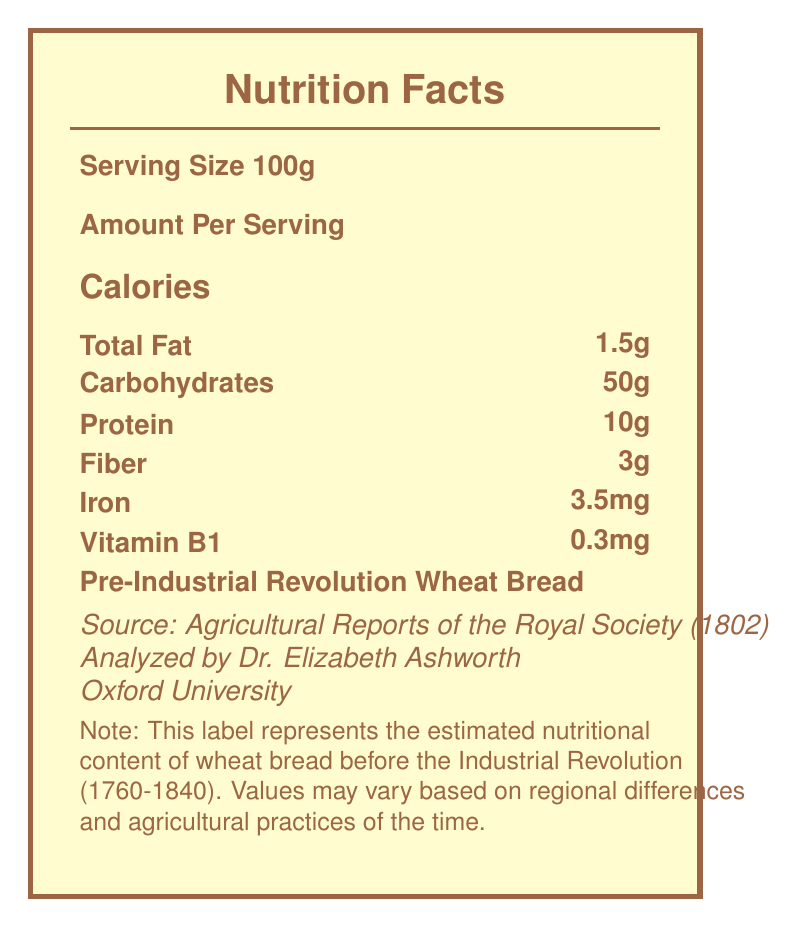who is the researcher mentioned in the document? The document states that Dr. Elizabeth Ashworth, a History Professor at Oxford University, conducted the research.
Answer: Dr. Elizabeth Ashworth what is the average decrease in iron content from pre to post-industrial staple foods? Under the "nutrient changes" section, it specifies an average decrease of 18% in iron content due to soil depletion and faster-growing varieties.
Answer: 18% what is the serving size of the food analyzed? The serving size mentioned in the document is 100g for both pre and post-industrial staple foods.
Answer: 100g how much did the calorie content of wheat bread increase after the Industrial Revolution? The calorie content increased from 250 calories (pre-industrial) to 265 calories (post-industrial), resulting in an increase of 15 calories.
Answer: 15 calories which vitamin's average content decreased by 15% due to storage methods and transportation time? The document lists that vitamin content decreased by 15% due to storage methods and transportation time in the "nutrient changes" section.
Answer: Vitamin content what caused an average decrease in fiber content? The document states that the average decrease of 12% in fiber content is due to the refinement of grains and milling processes.
Answer: Refinement of grains and milling processes by what percentage did pre-industrial revolution wheat bread have more protein compared to post-industrial wheat bread? A. 10% B. 11.1% C. 12.5% D. 14.3% Pre-industrial wheat bread had 10g of protein while post-industrial had 9g, resulting in (10-9)/9*100% = 11.1% more protein pre-industrial.
Answer: B. 11.1% which of the following is not mentioned as an industrial impact on staple foods? 1. Mechanization of farming 2. Food preservation techniques 3. Development of GMOs 4. Urbanization and changing dietary patterns The document lists "Introduction of chemical fertilizers," "Mechanization of farming," "Food preservation techniques," and "Urbanization and changing dietary patterns," but does not mention the development of GMOs.
Answer: 3. Development of GMOs is vitamin C content higher in pre-industrial or post-industrial potatoes? The document shows that pre-industrial potatoes have 19.7mg of vitamin C compared to 17.1mg in post-industrial potatoes, indicating higher content in pre-industrial potatoes.
Answer: Pre-industrial summarize the main idea of the document in one or two sentences. The document focuses on the nutritional differences in staple foods from pre to post-industrial times and the contributing factors of these changes, reflecting on the broader implications for public health and agricultural policies.
Answer: The document provides a comparative nutrient analysis of staple foods like wheat bread and potatoes before and after the Industrial Revolution, highlighting changes in caloric value and nutrient content due to industrial impacts such as chemical fertilizers, mechanization, and urbanization. what are the nutrient values for Vitamin B1 in post-industrial wheat bread? The document specifies that the Vitamin B1 content in post-industrial wheat bread is 0.2mg per 100g serving.
Answer: 0.2mg why did potassium content decrease in post-industrial potatoes? The specific reasons for the decrease in potassium content in post-industrial potatoes are not provided in the document.
Answer: Not enough information 